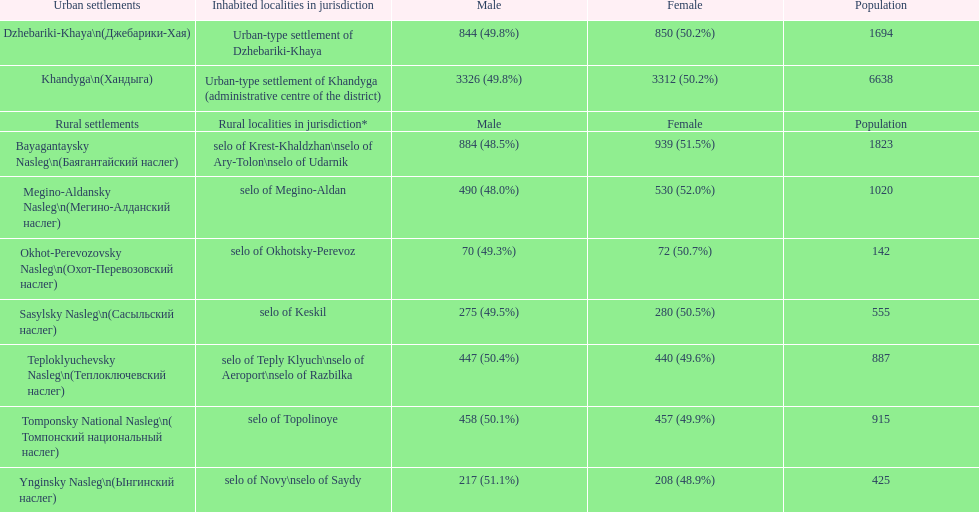What is the total population in dzhebariki-khaya? 1694. 